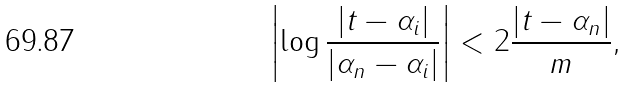Convert formula to latex. <formula><loc_0><loc_0><loc_500><loc_500>\left | \log \frac { | t - \alpha _ { i } | } { | \alpha _ { n } - \alpha _ { i } | } \right | < 2 \frac { | t - \alpha _ { n } | } { m } ,</formula> 